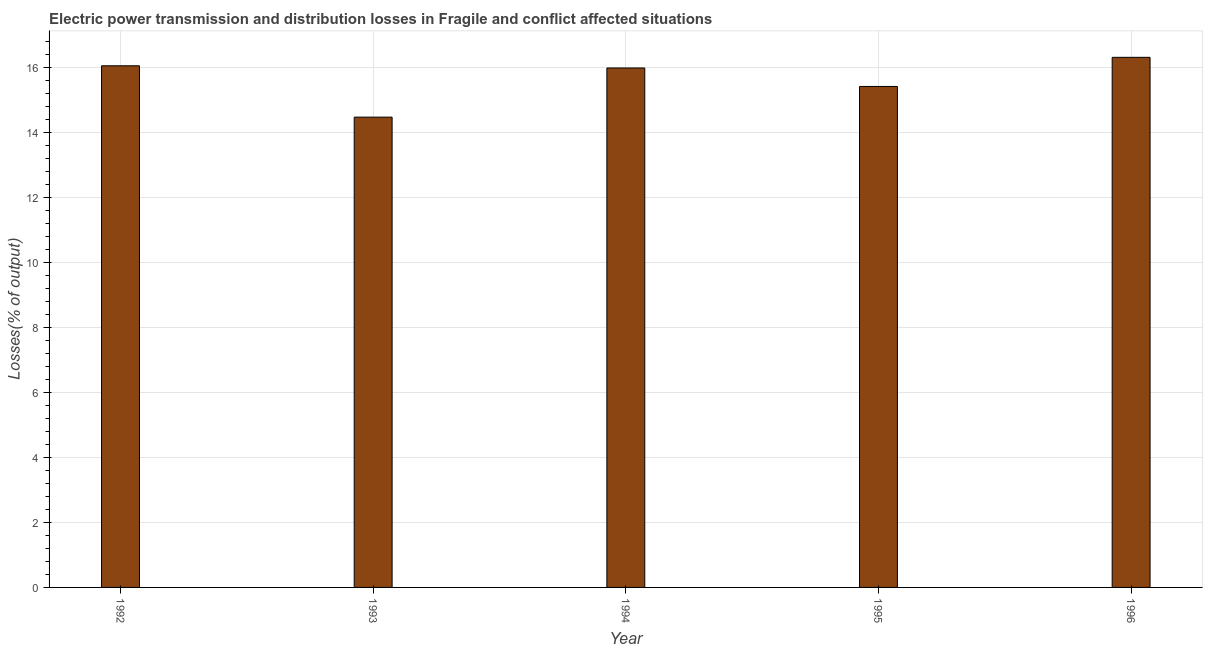Does the graph contain any zero values?
Your answer should be very brief. No. What is the title of the graph?
Keep it short and to the point. Electric power transmission and distribution losses in Fragile and conflict affected situations. What is the label or title of the X-axis?
Keep it short and to the point. Year. What is the label or title of the Y-axis?
Provide a succinct answer. Losses(% of output). What is the electric power transmission and distribution losses in 1995?
Give a very brief answer. 15.42. Across all years, what is the maximum electric power transmission and distribution losses?
Make the answer very short. 16.31. Across all years, what is the minimum electric power transmission and distribution losses?
Make the answer very short. 14.47. In which year was the electric power transmission and distribution losses maximum?
Provide a succinct answer. 1996. In which year was the electric power transmission and distribution losses minimum?
Your response must be concise. 1993. What is the sum of the electric power transmission and distribution losses?
Give a very brief answer. 78.24. What is the difference between the electric power transmission and distribution losses in 1992 and 1995?
Offer a terse response. 0.64. What is the average electric power transmission and distribution losses per year?
Your response must be concise. 15.65. What is the median electric power transmission and distribution losses?
Your answer should be compact. 15.98. What is the difference between the highest and the second highest electric power transmission and distribution losses?
Offer a terse response. 0.26. What is the difference between the highest and the lowest electric power transmission and distribution losses?
Keep it short and to the point. 1.84. Are the values on the major ticks of Y-axis written in scientific E-notation?
Your response must be concise. No. What is the Losses(% of output) in 1992?
Give a very brief answer. 16.05. What is the Losses(% of output) of 1993?
Make the answer very short. 14.47. What is the Losses(% of output) of 1994?
Your response must be concise. 15.98. What is the Losses(% of output) of 1995?
Keep it short and to the point. 15.42. What is the Losses(% of output) of 1996?
Ensure brevity in your answer.  16.31. What is the difference between the Losses(% of output) in 1992 and 1993?
Keep it short and to the point. 1.58. What is the difference between the Losses(% of output) in 1992 and 1994?
Offer a terse response. 0.07. What is the difference between the Losses(% of output) in 1992 and 1995?
Your answer should be very brief. 0.64. What is the difference between the Losses(% of output) in 1992 and 1996?
Keep it short and to the point. -0.26. What is the difference between the Losses(% of output) in 1993 and 1994?
Provide a succinct answer. -1.51. What is the difference between the Losses(% of output) in 1993 and 1995?
Your answer should be compact. -0.94. What is the difference between the Losses(% of output) in 1993 and 1996?
Ensure brevity in your answer.  -1.84. What is the difference between the Losses(% of output) in 1994 and 1995?
Provide a succinct answer. 0.57. What is the difference between the Losses(% of output) in 1994 and 1996?
Give a very brief answer. -0.33. What is the difference between the Losses(% of output) in 1995 and 1996?
Your response must be concise. -0.9. What is the ratio of the Losses(% of output) in 1992 to that in 1993?
Provide a short and direct response. 1.11. What is the ratio of the Losses(% of output) in 1992 to that in 1994?
Ensure brevity in your answer.  1. What is the ratio of the Losses(% of output) in 1992 to that in 1995?
Your answer should be very brief. 1.04. What is the ratio of the Losses(% of output) in 1993 to that in 1994?
Provide a short and direct response. 0.91. What is the ratio of the Losses(% of output) in 1993 to that in 1995?
Ensure brevity in your answer.  0.94. What is the ratio of the Losses(% of output) in 1993 to that in 1996?
Give a very brief answer. 0.89. What is the ratio of the Losses(% of output) in 1994 to that in 1996?
Offer a very short reply. 0.98. What is the ratio of the Losses(% of output) in 1995 to that in 1996?
Your answer should be very brief. 0.94. 